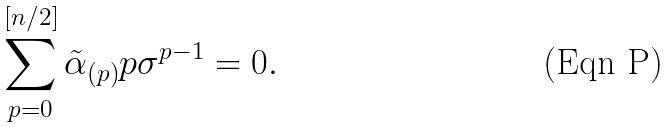<formula> <loc_0><loc_0><loc_500><loc_500>\sum _ { p = 0 } ^ { [ n / 2 ] } { \tilde { \alpha } } _ { ( p ) } p \sigma ^ { p - 1 } = 0 .</formula> 